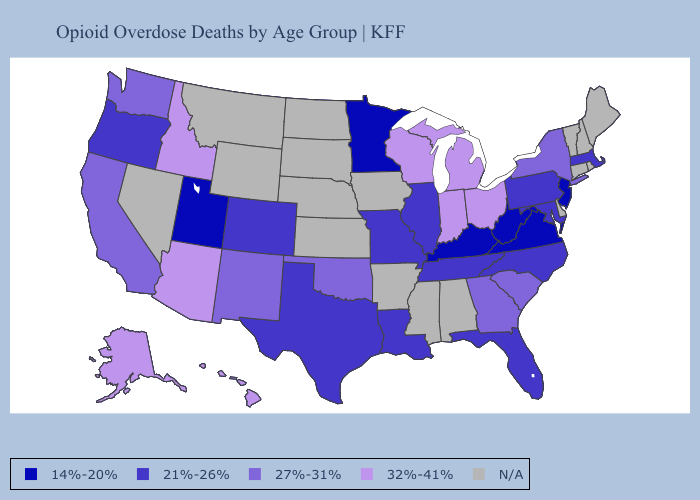Among the states that border Indiana , which have the highest value?
Answer briefly. Michigan, Ohio. What is the highest value in states that border Colorado?
Answer briefly. 32%-41%. Is the legend a continuous bar?
Answer briefly. No. Does Pennsylvania have the lowest value in the Northeast?
Be succinct. No. Name the states that have a value in the range 21%-26%?
Give a very brief answer. Colorado, Florida, Illinois, Louisiana, Maryland, Massachusetts, Missouri, North Carolina, Oregon, Pennsylvania, Tennessee, Texas. What is the lowest value in states that border Nebraska?
Keep it brief. 21%-26%. Does Virginia have the lowest value in the USA?
Give a very brief answer. Yes. Does New Jersey have the lowest value in the Northeast?
Concise answer only. Yes. Does Idaho have the highest value in the USA?
Quick response, please. Yes. What is the value of Washington?
Be succinct. 27%-31%. What is the value of Virginia?
Concise answer only. 14%-20%. Does Illinois have the lowest value in the USA?
Quick response, please. No. Among the states that border Utah , which have the highest value?
Short answer required. Arizona, Idaho. 